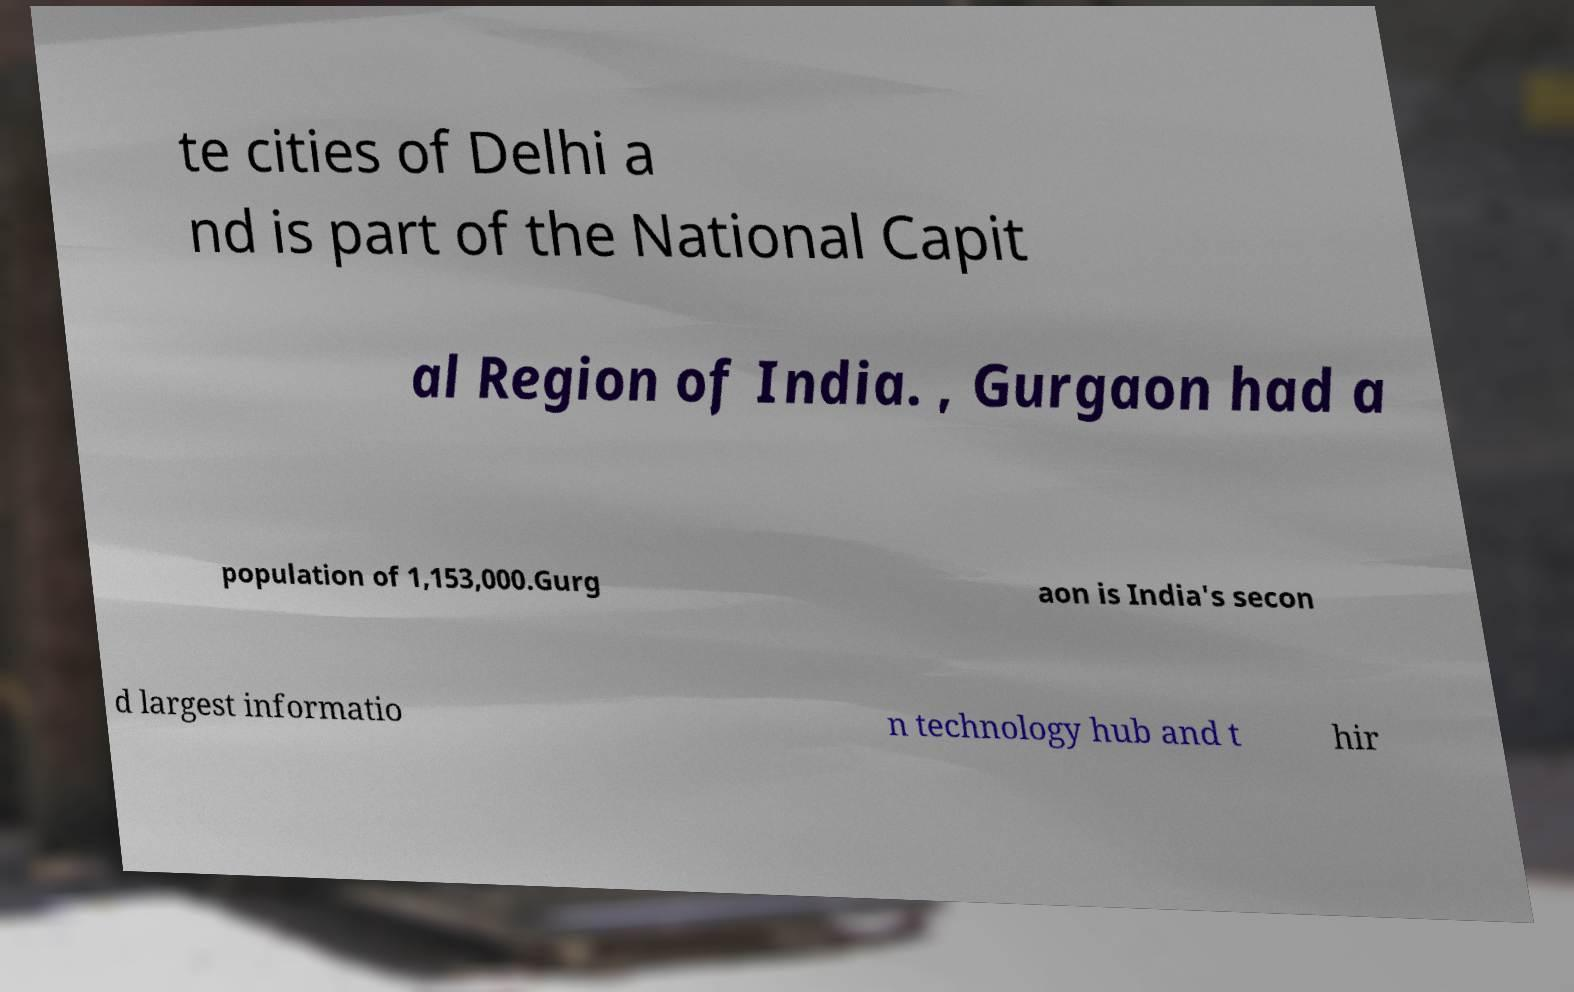For documentation purposes, I need the text within this image transcribed. Could you provide that? te cities of Delhi a nd is part of the National Capit al Region of India. , Gurgaon had a population of 1,153,000.Gurg aon is India's secon d largest informatio n technology hub and t hir 